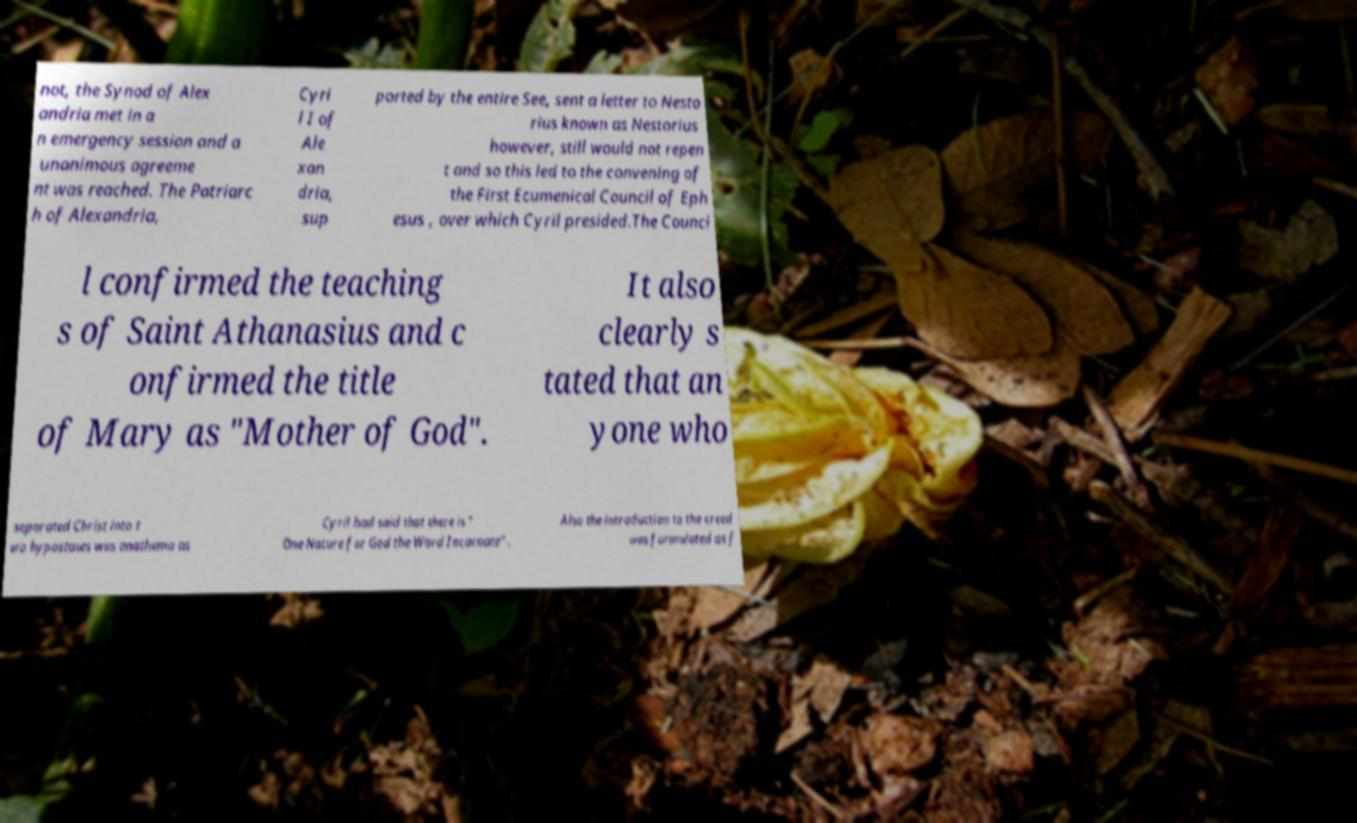Please identify and transcribe the text found in this image. not, the Synod of Alex andria met in a n emergency session and a unanimous agreeme nt was reached. The Patriarc h of Alexandria, Cyri l I of Ale xan dria, sup ported by the entire See, sent a letter to Nesto rius known as Nestorius however, still would not repen t and so this led to the convening of the First Ecumenical Council of Eph esus , over which Cyril presided.The Counci l confirmed the teaching s of Saint Athanasius and c onfirmed the title of Mary as "Mother of God". It also clearly s tated that an yone who separated Christ into t wo hypostases was anathema as Cyril had said that there is " One Nature for God the Word Incarnate" . Also the introduction to the creed was formulated as f 